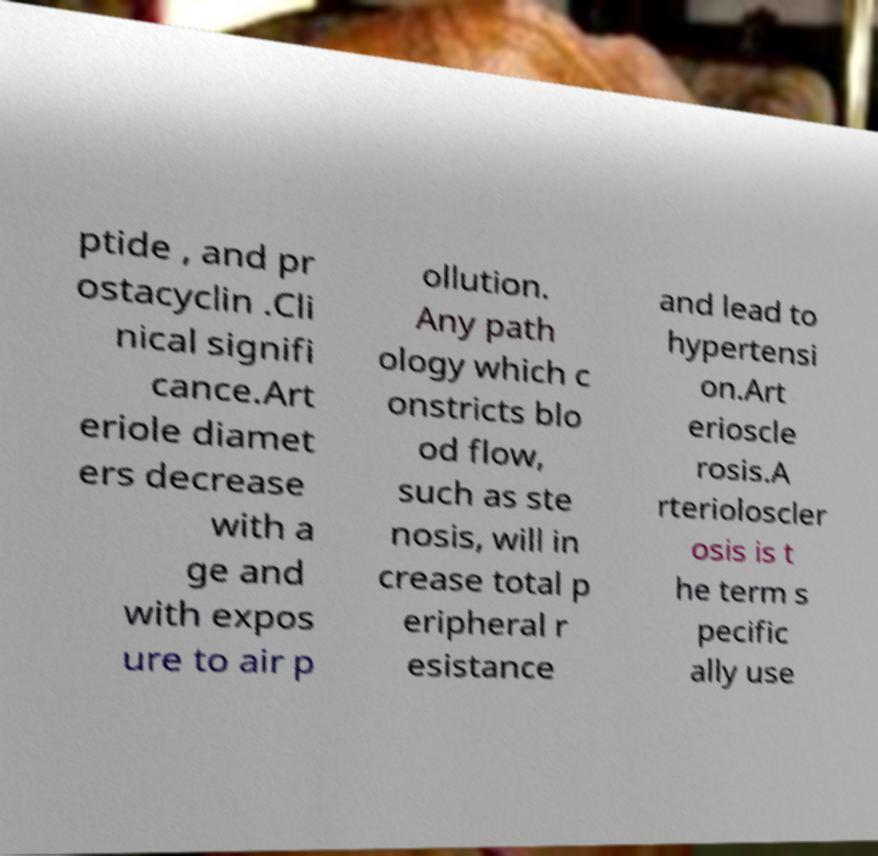Please read and relay the text visible in this image. What does it say? ptide , and pr ostacyclin .Cli nical signifi cance.Art eriole diamet ers decrease with a ge and with expos ure to air p ollution. Any path ology which c onstricts blo od flow, such as ste nosis, will in crease total p eripheral r esistance and lead to hypertensi on.Art erioscle rosis.A rterioloscler osis is t he term s pecific ally use 